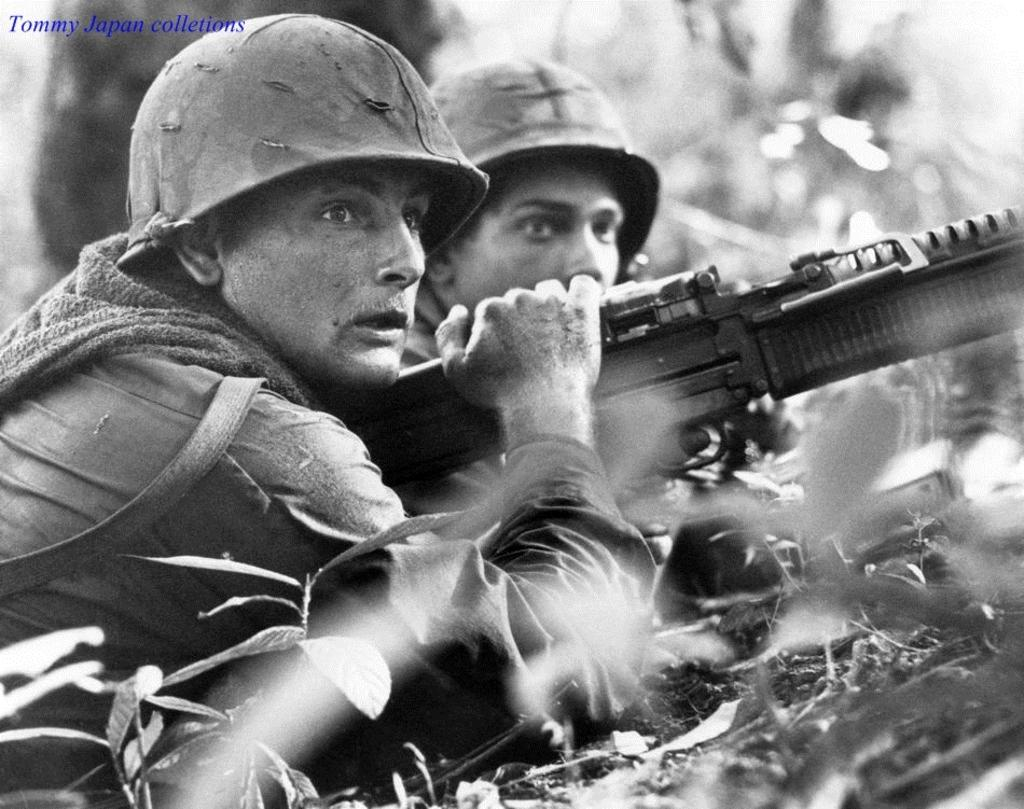How many people are in the image? There are two persons in the image. What is one person holding in the image? One person is holding a gun. What is the color scheme of the image? The image is in black and white. Can you see any goldfish swimming in the image? There are no goldfish present in the image. How many legs does the person with the gun have in the image? The person with the gun has two legs, but this question is irrelevant to the image's content and is considered an "absurd" question. 